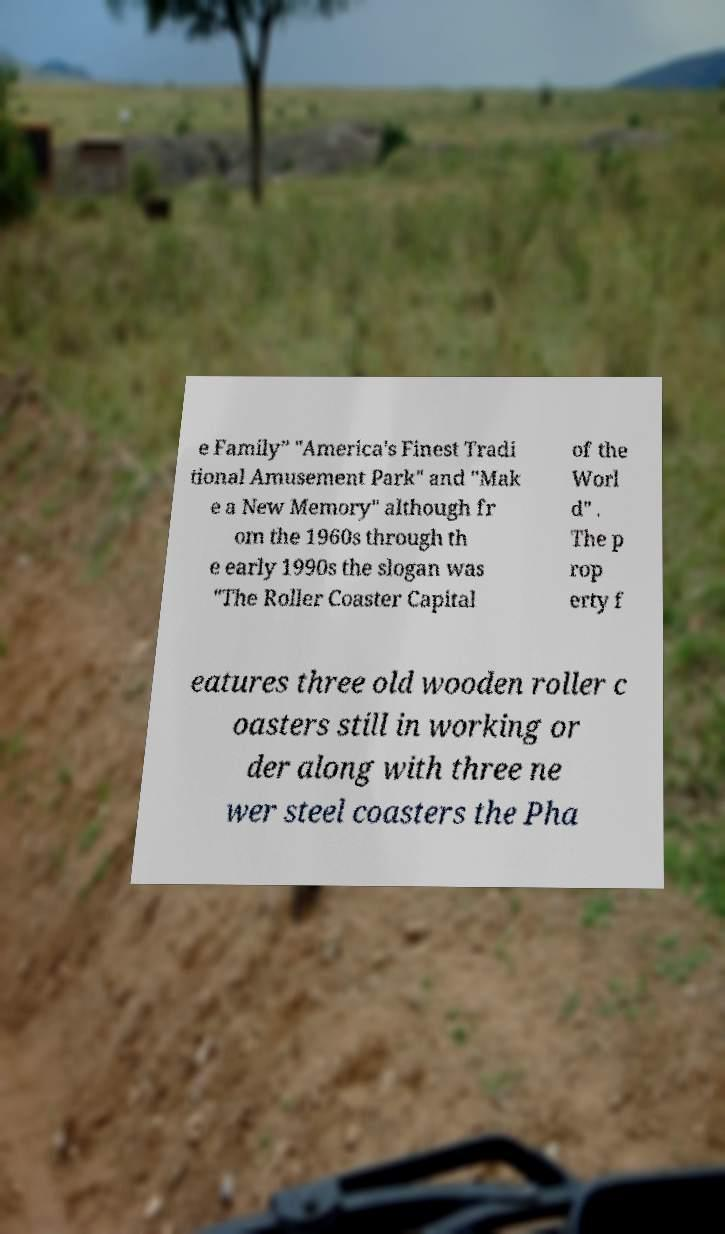For documentation purposes, I need the text within this image transcribed. Could you provide that? e Family” "America's Finest Tradi tional Amusement Park" and "Mak e a New Memory" although fr om the 1960s through th e early 1990s the slogan was "The Roller Coaster Capital of the Worl d" . The p rop erty f eatures three old wooden roller c oasters still in working or der along with three ne wer steel coasters the Pha 